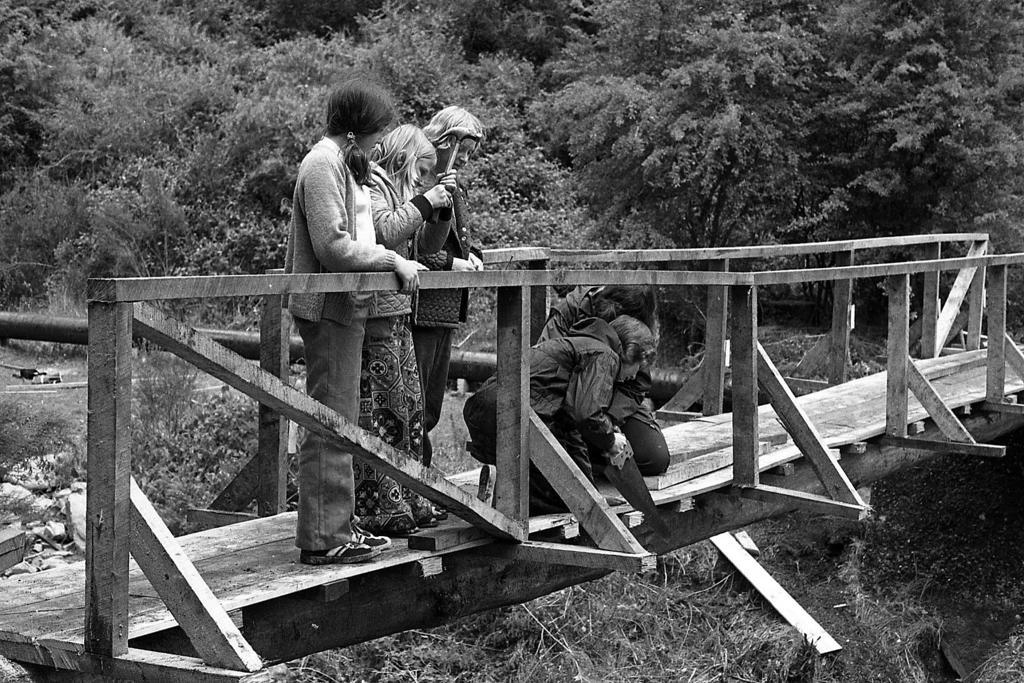How would you summarize this image in a sentence or two? In this image there are few persons standing on the wooden bridge having fence. A person is sawing the wood with the hand saw. Background there are few plants and trees. 